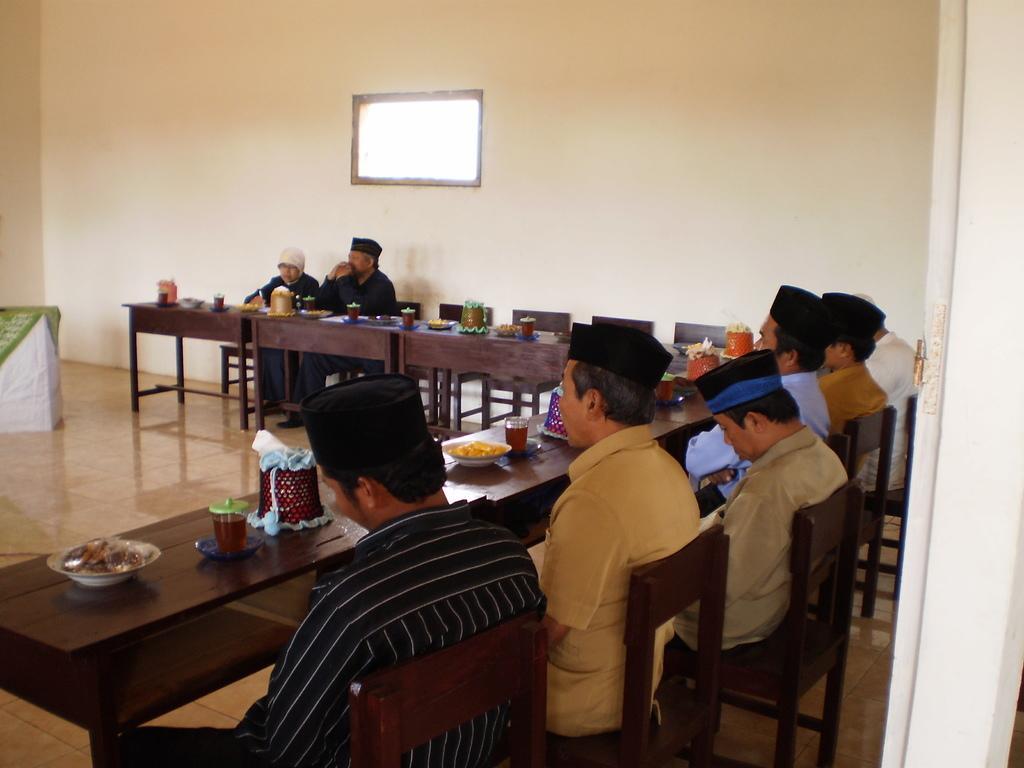In one or two sentences, can you explain what this image depicts? The picture consists of few men sat on chair in front of dining table,there are food,glasses,bowls on the table. 